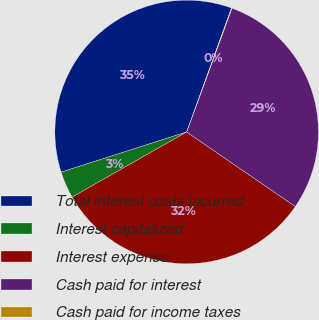<chart> <loc_0><loc_0><loc_500><loc_500><pie_chart><fcel>Total interest costs incurred<fcel>Interest capitalized<fcel>Interest expense<fcel>Cash paid for interest<fcel>Cash paid for income taxes<nl><fcel>35.45%<fcel>3.3%<fcel>32.21%<fcel>28.98%<fcel>0.07%<nl></chart> 